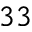Convert formula to latex. <formula><loc_0><loc_0><loc_500><loc_500>^ { 3 3 }</formula> 